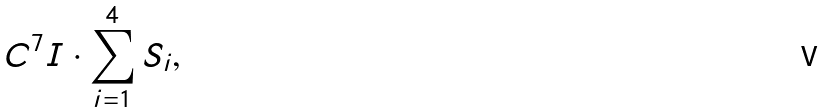Convert formula to latex. <formula><loc_0><loc_0><loc_500><loc_500>C ^ { 7 } { I } \cdot \sum _ { i = 1 } ^ { 4 } { S } _ { i } ,</formula> 